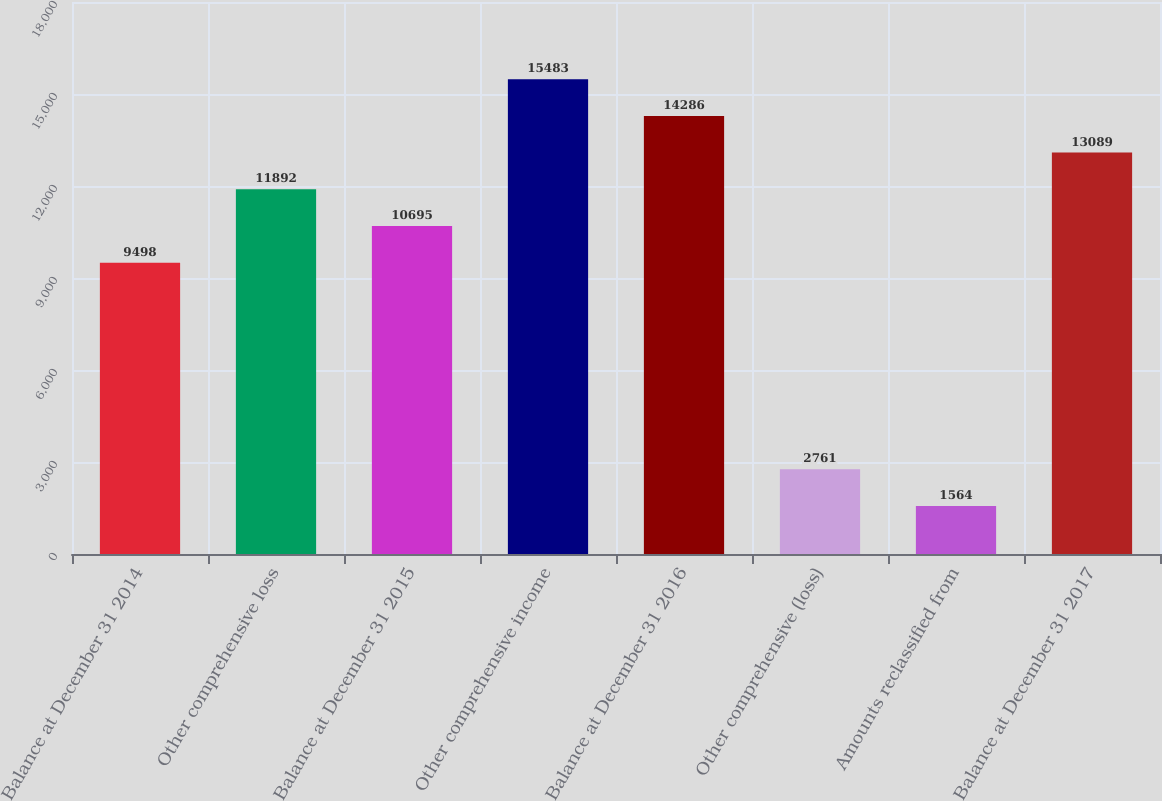Convert chart to OTSL. <chart><loc_0><loc_0><loc_500><loc_500><bar_chart><fcel>Balance at December 31 2014<fcel>Other comprehensive loss<fcel>Balance at December 31 2015<fcel>Other comprehensive income<fcel>Balance at December 31 2016<fcel>Other comprehensive (loss)<fcel>Amounts reclassified from<fcel>Balance at December 31 2017<nl><fcel>9498<fcel>11892<fcel>10695<fcel>15483<fcel>14286<fcel>2761<fcel>1564<fcel>13089<nl></chart> 